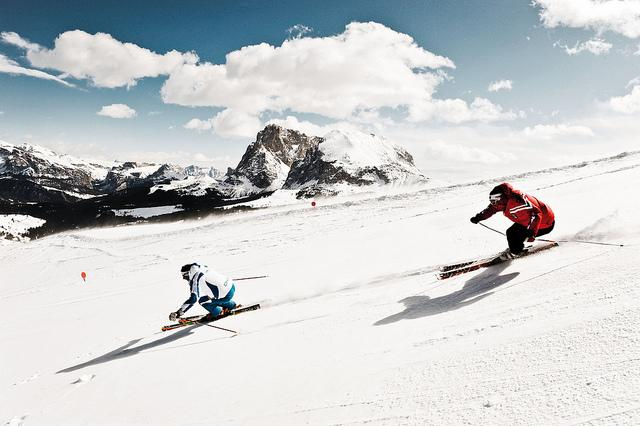What kind of skis are the two using in this mountain range? downhill 